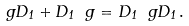<formula> <loc_0><loc_0><loc_500><loc_500>\ g D _ { 1 } + D _ { 1 } \ g = D _ { 1 } \ g D _ { 1 } \, .</formula> 